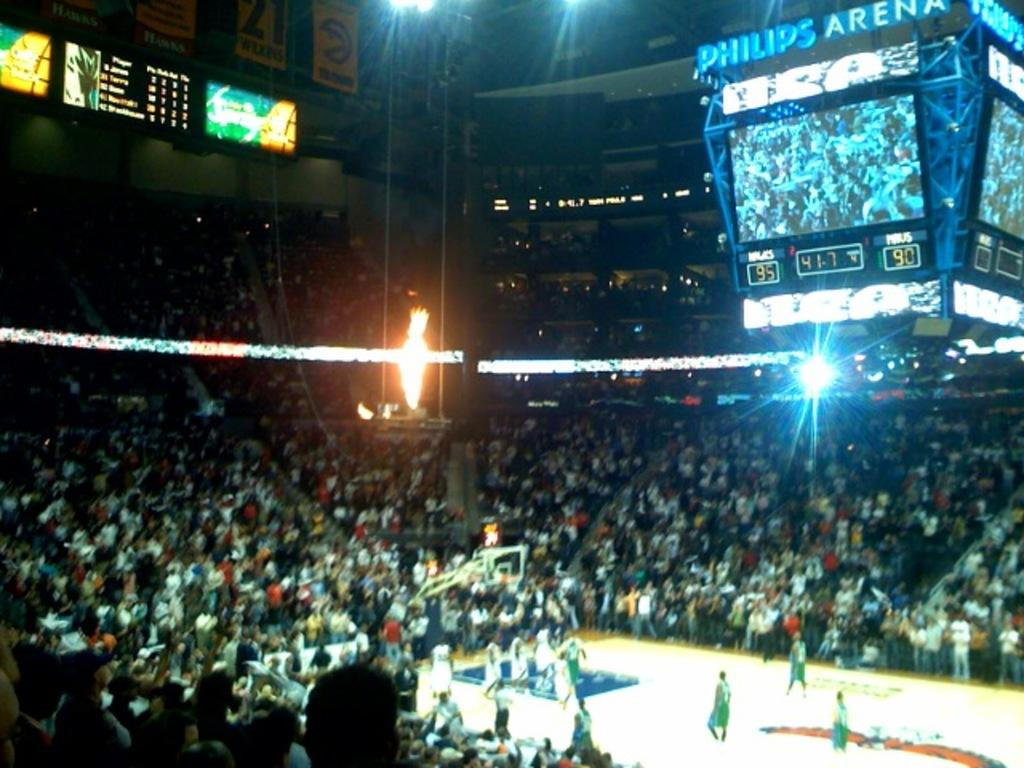<image>
Relay a brief, clear account of the picture shown. Philips arena showing a live basketball game with fire 